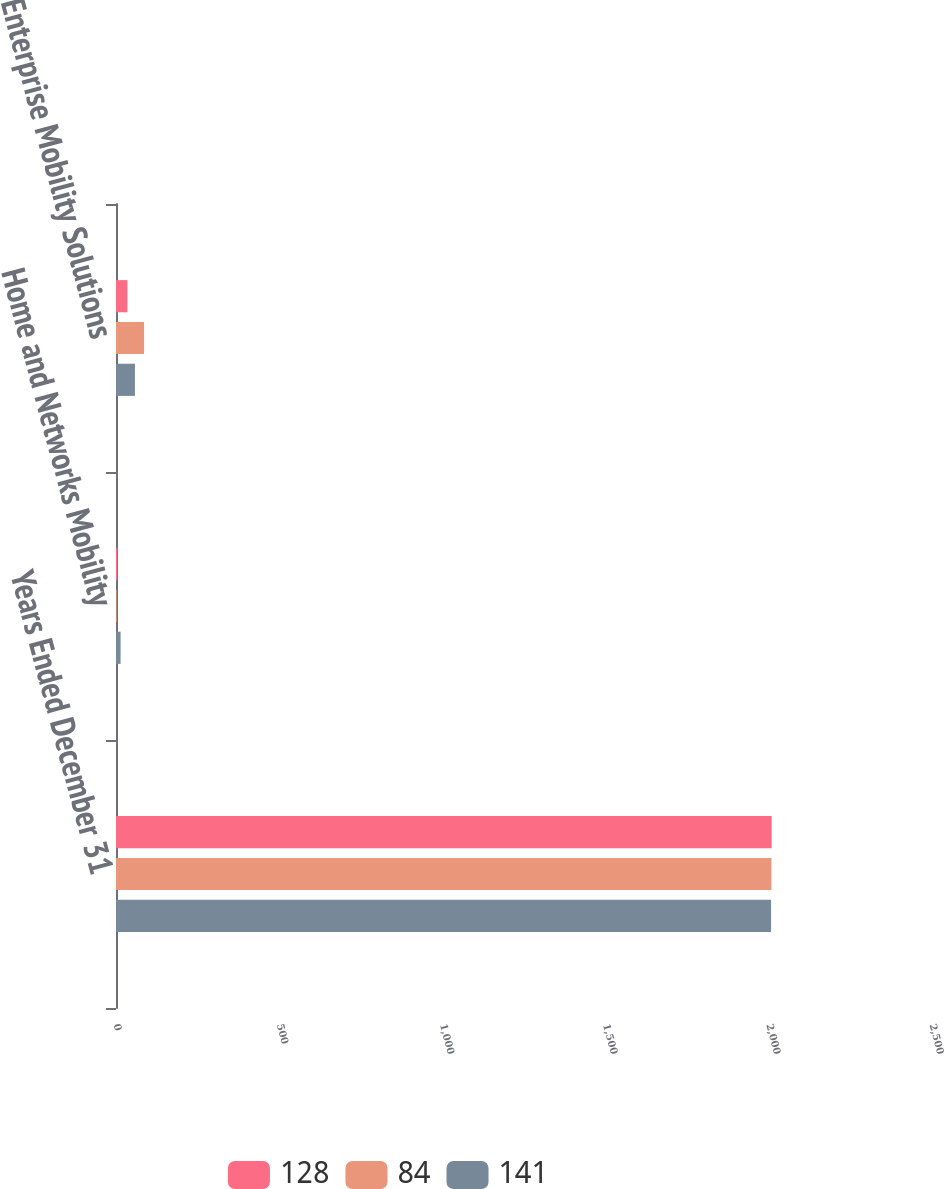Convert chart to OTSL. <chart><loc_0><loc_0><loc_500><loc_500><stacked_bar_chart><ecel><fcel>Years Ended December 31<fcel>Home and Networks Mobility<fcel>Enterprise Mobility Solutions<nl><fcel>128<fcel>2009<fcel>4<fcel>35<nl><fcel>84<fcel>2008<fcel>2<fcel>86<nl><fcel>141<fcel>2007<fcel>14<fcel>58<nl></chart> 